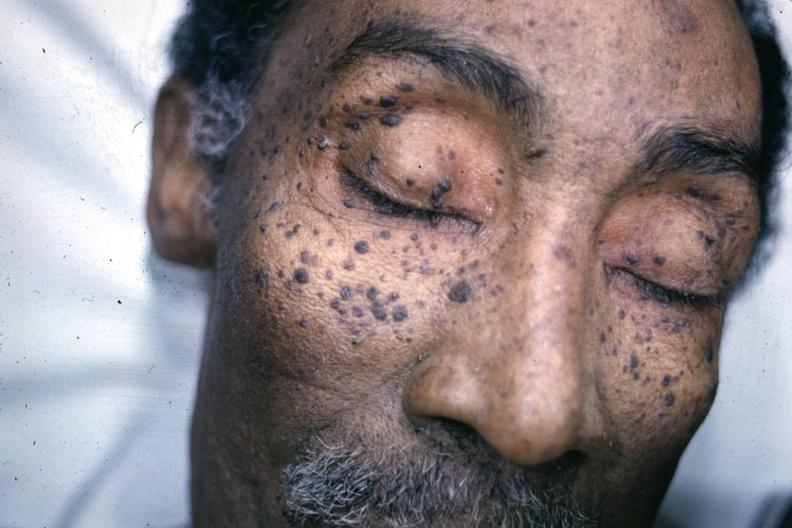where is this?
Answer the question using a single word or phrase. Skin 